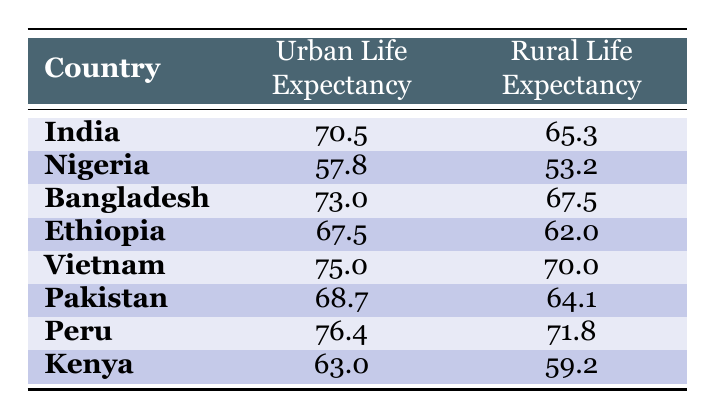What is the urban life expectancy in India? The table indicates that India's urban life expectancy is listed as 70.5 years.
Answer: 70.5 What is the difference in life expectancy between urban and rural populations in Nigeria? To find the difference, subtract Nigeria's rural life expectancy (53.2) from its urban life expectancy (57.8): 57.8 - 53.2 = 4.6 years.
Answer: 4.6 Which country has the highest urban life expectancy? By looking at the urban life expectancy values in the table, Vietnam has the highest value at 75.0 years.
Answer: Vietnam Is the rural life expectancy in Ethiopia greater than the rural life expectancy in Kenya? The rural life expectancy in Ethiopia is 62.0 years, whereas in Kenya it is 59.2 years. Therefore, 62.0 is greater than 59.2.
Answer: Yes What is the average rural life expectancy across all countries listed in the table? To find the average, add up all the rural life expectancies: 65.3 (India) + 53.2 (Nigeria) + 67.5 (Bangladesh) + 62.0 (Ethiopia) + 70.0 (Vietnam) + 64.1 (Pakistan) + 71.8 (Peru) + 59.2 (Kenya) = 469.1. Then divide by the number of countries (8): 469.1 / 8 = 58.64.
Answer: 58.64 What is the life expectancy of urban populations in Bangladesh? According to the table, the urban life expectancy in Bangladesh is 73.0 years.
Answer: 73.0 